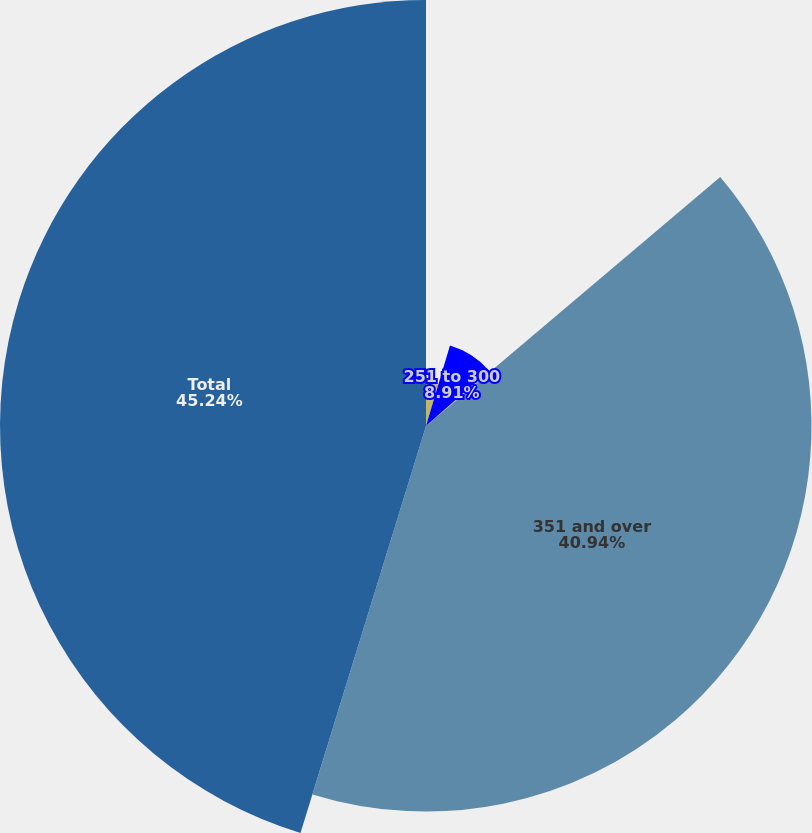Convert chart. <chart><loc_0><loc_0><loc_500><loc_500><pie_chart><fcel>201 to 250<fcel>251 to 300<fcel>301 to 350<fcel>351 and over<fcel>Total<nl><fcel>4.61%<fcel>8.91%<fcel>0.3%<fcel>40.94%<fcel>45.24%<nl></chart> 